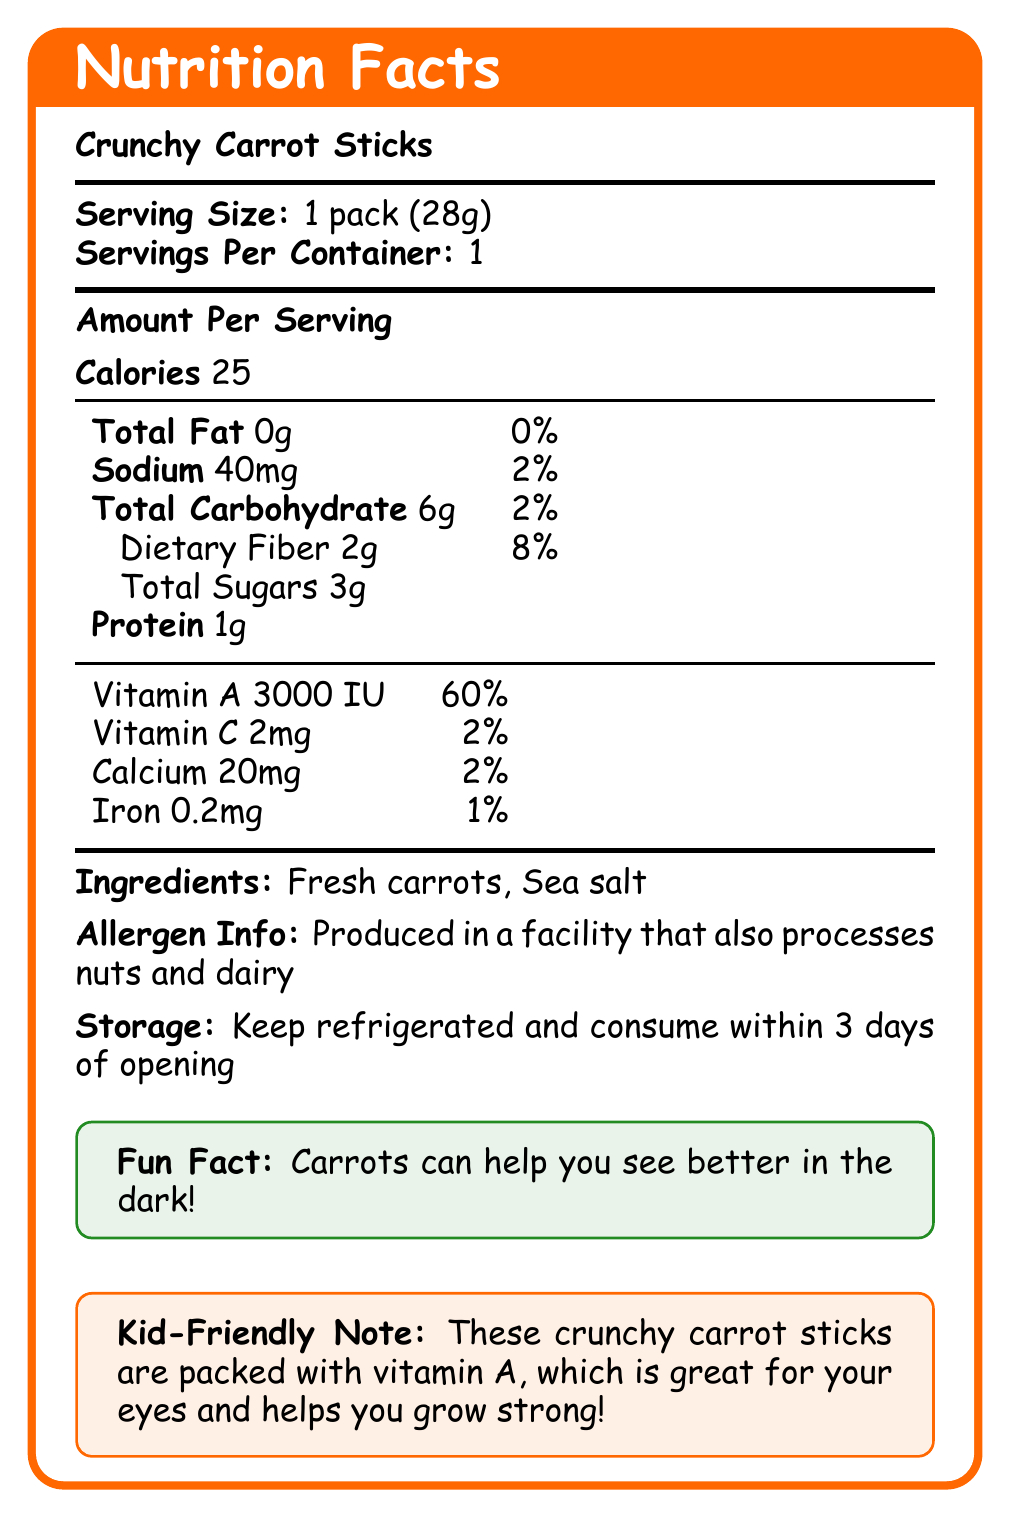what is the serving size for Crunchy Carrot Sticks? The serving size is listed at the beginning of the document as "Serving Size: 1 pack (28g)".
Answer: 1 pack (28g) how many calories are in one serving of Crunchy Carrot Sticks? The number of calories per serving is clearly stated in the "Amount Per Serving" section as "Calories 25".
Answer: 25 what percentage of the daily vitamin A value does one pack provide? The document lists the vitamin A content as "Vitamin A 3000 IU" and "daily value 60%" under the vitamins section.
Answer: 60% how much dietary fiber is in one pack of Crunchy Carrot Sticks? The dietary fiber content is listed under the "Total Carbohydrate" section as "Dietary Fiber 2g".
Answer: 2g what are the two ingredients of Crunchy Carrot Sticks? The ingredients list in the document states "Ingredients: Fresh carrots, Sea salt".
Answer: Fresh carrots, Sea salt how should you store Crunchy Carrot Sticks after opening? The storage instructions are listed towards the end of the document.
Answer: Keep refrigerated and consume within 3 days of opening what is the sodium content in one pack? The sodium content is listed as "Sodium 40mg" in the "Amount Per Serving" section.
Answer: 40mg what is the fun fact about carrots given in the document? The document includes a fun fact towards the end that states "Carrots can help you see better in the dark!".
Answer: Carrots can help you see better in the dark! how much protein is in one serving of Crunchy Carrot Sticks? A. 0g B. 1g C. 2g D. 3g The protein content is listed as "Protein 1g" in the "Amount Per Serving" section.
Answer: B. 1g which of the following nutrients is highest in its daily value percentage per serving? A. Vitamin C B. Calcium C. Iron D. Vitamin A The daily value percentages listed are 2% for Vitamin C, 2% for Calcium, 1% for Iron, and 60% for Vitamin A. Therefore, Vitamin A has the highest daily value percentage per serving.
Answer: D. Vitamin A does the Crunchy Carrot Sticks contain any allergens directly? The document states "Produced in a facility that also processes nuts and dairy", indicating potential cross-contact, but does not list any direct allergens in the ingredients.
Answer: No summarize the main idea of the document about Crunchy Carrot Sticks. The document details the nutritional content, ingredients, storage instructions, and fun facts for Crunchy Carrot Sticks. It emphasizes the health benefits, especially the high Vitamin A content which is good for eyesight.
Answer: The document provides detailed nutritional information about Crunchy Carrot Sticks, including serving size, calories, and nutrient content. It highlights that the snack is low in calories but high in Vitamin A. Ingredients, storage instructions, and fun facts are also included. how can carrots improve your health according to the fun fact? The fun fact states "Carrots can help you see better in the dark!", indicating their benefit for eyesight.
Answer: Improve eyesight, especially seeing better in the dark how long can you keep Crunchy Carrot Sticks after opening the package? According to the storage instructions, "Keep refrigerated and consume within 3 days of opening".
Answer: 3 days what is the iron content in one pack? The iron content is listed in the vitamin and minerals section as "Iron 0.2mg".
Answer: 0.2mg what is the source of the daily value percentages provided in the document? The document provides daily value percentages but does not specify the source or guidelines they follow.
Answer: Cannot be determined 